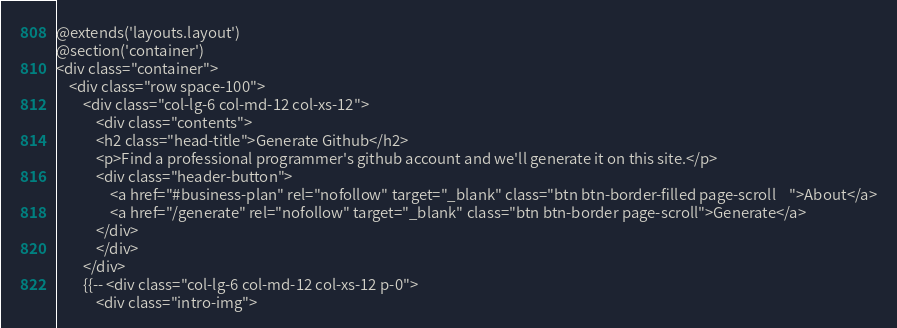<code> <loc_0><loc_0><loc_500><loc_500><_PHP_>@extends('layouts.layout')
@section('container')
<div class="container">      
    <div class="row space-100">
        <div class="col-lg-6 col-md-12 col-xs-12">
            <div class="contents">
            <h2 class="head-title">Generate Github</h2>
            <p>Find a professional programmer's github account and we'll generate it on this site.</p>
            <div class="header-button">
                <a href="#business-plan" rel="nofollow" target="_blank" class="btn btn-border-filled page-scroll    ">About</a>
                <a href="/generate" rel="nofollow" target="_blank" class="btn btn-border page-scroll">Generate</a>
            </div>
            </div>
        </div>
        {{-- <div class="col-lg-6 col-md-12 col-xs-12 p-0">
            <div class="intro-img"></code> 